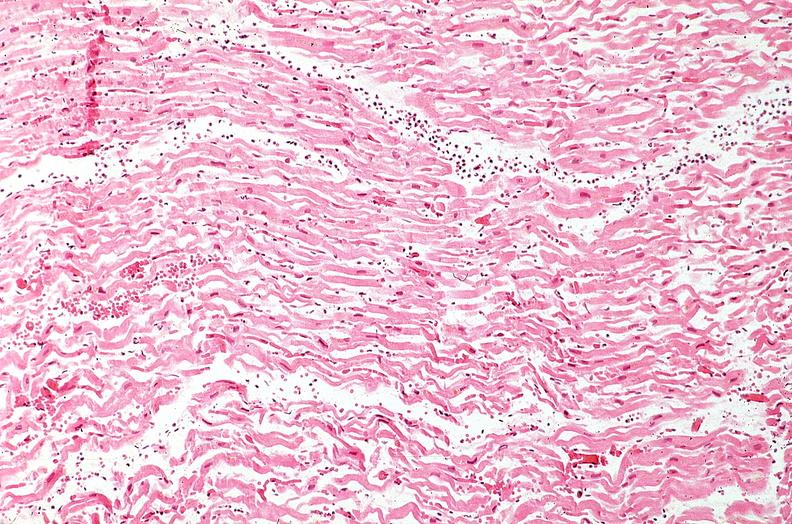does this image show heart, myocardial infarction, wavey fiber change, necrtosis, hemorrhage, and dissection?
Answer the question using a single word or phrase. Yes 